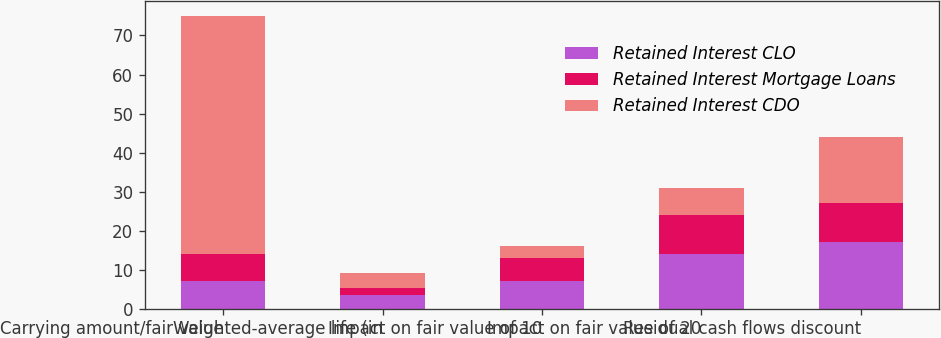Convert chart to OTSL. <chart><loc_0><loc_0><loc_500><loc_500><stacked_bar_chart><ecel><fcel>Carrying amount/fair value<fcel>Weighted-average life (in<fcel>Impact on fair value of 10<fcel>Impact on fair value of 20<fcel>Residual cash flows discount<nl><fcel>Retained Interest CLO<fcel>7<fcel>3.54<fcel>7<fcel>14<fcel>17<nl><fcel>Retained Interest Mortgage Loans<fcel>7<fcel>1.87<fcel>6<fcel>10<fcel>10<nl><fcel>Retained Interest CDO<fcel>61<fcel>3.69<fcel>3<fcel>7<fcel>16.9<nl></chart> 